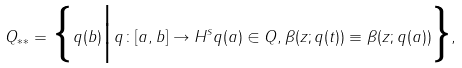Convert formula to latex. <formula><loc_0><loc_0><loc_500><loc_500>Q _ { * * } = \Big \{ q ( b ) \Big | \, q \colon [ a , b ] \to H ^ { s } q ( a ) \in Q , \beta ( z ; q ( t ) ) \equiv \beta ( z ; q ( a ) ) \Big \} ,</formula> 